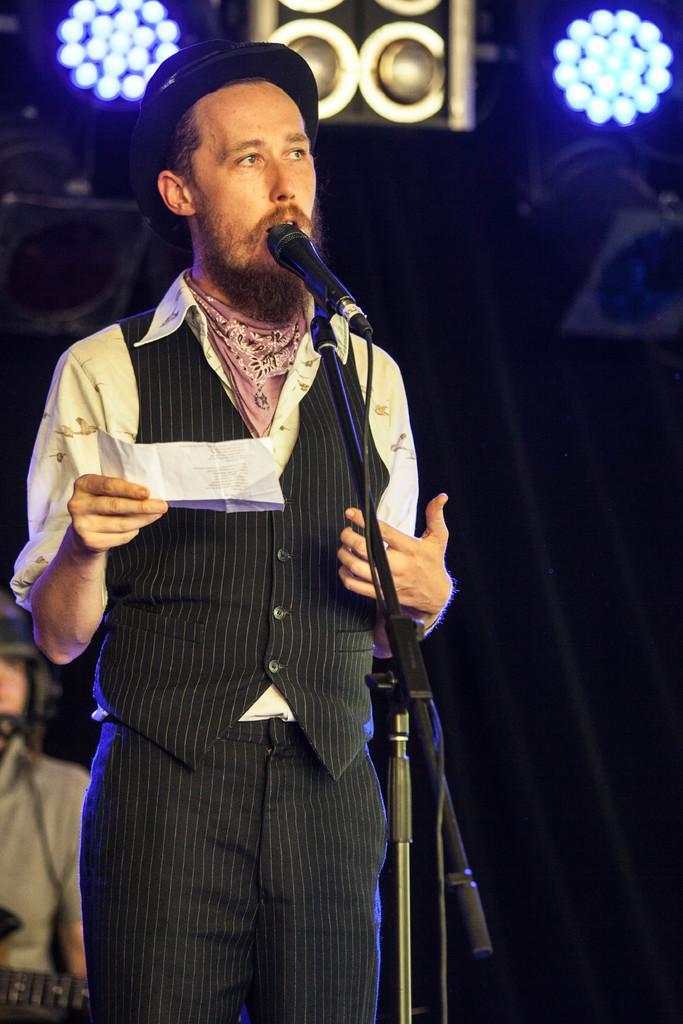Could you give a brief overview of what you see in this image? In this picture we can see a man wore a cap, holding a paper with his hand and in front of him we can see a mic and at the back of him we can see a person, lights, some objects and in the background it is dark. 